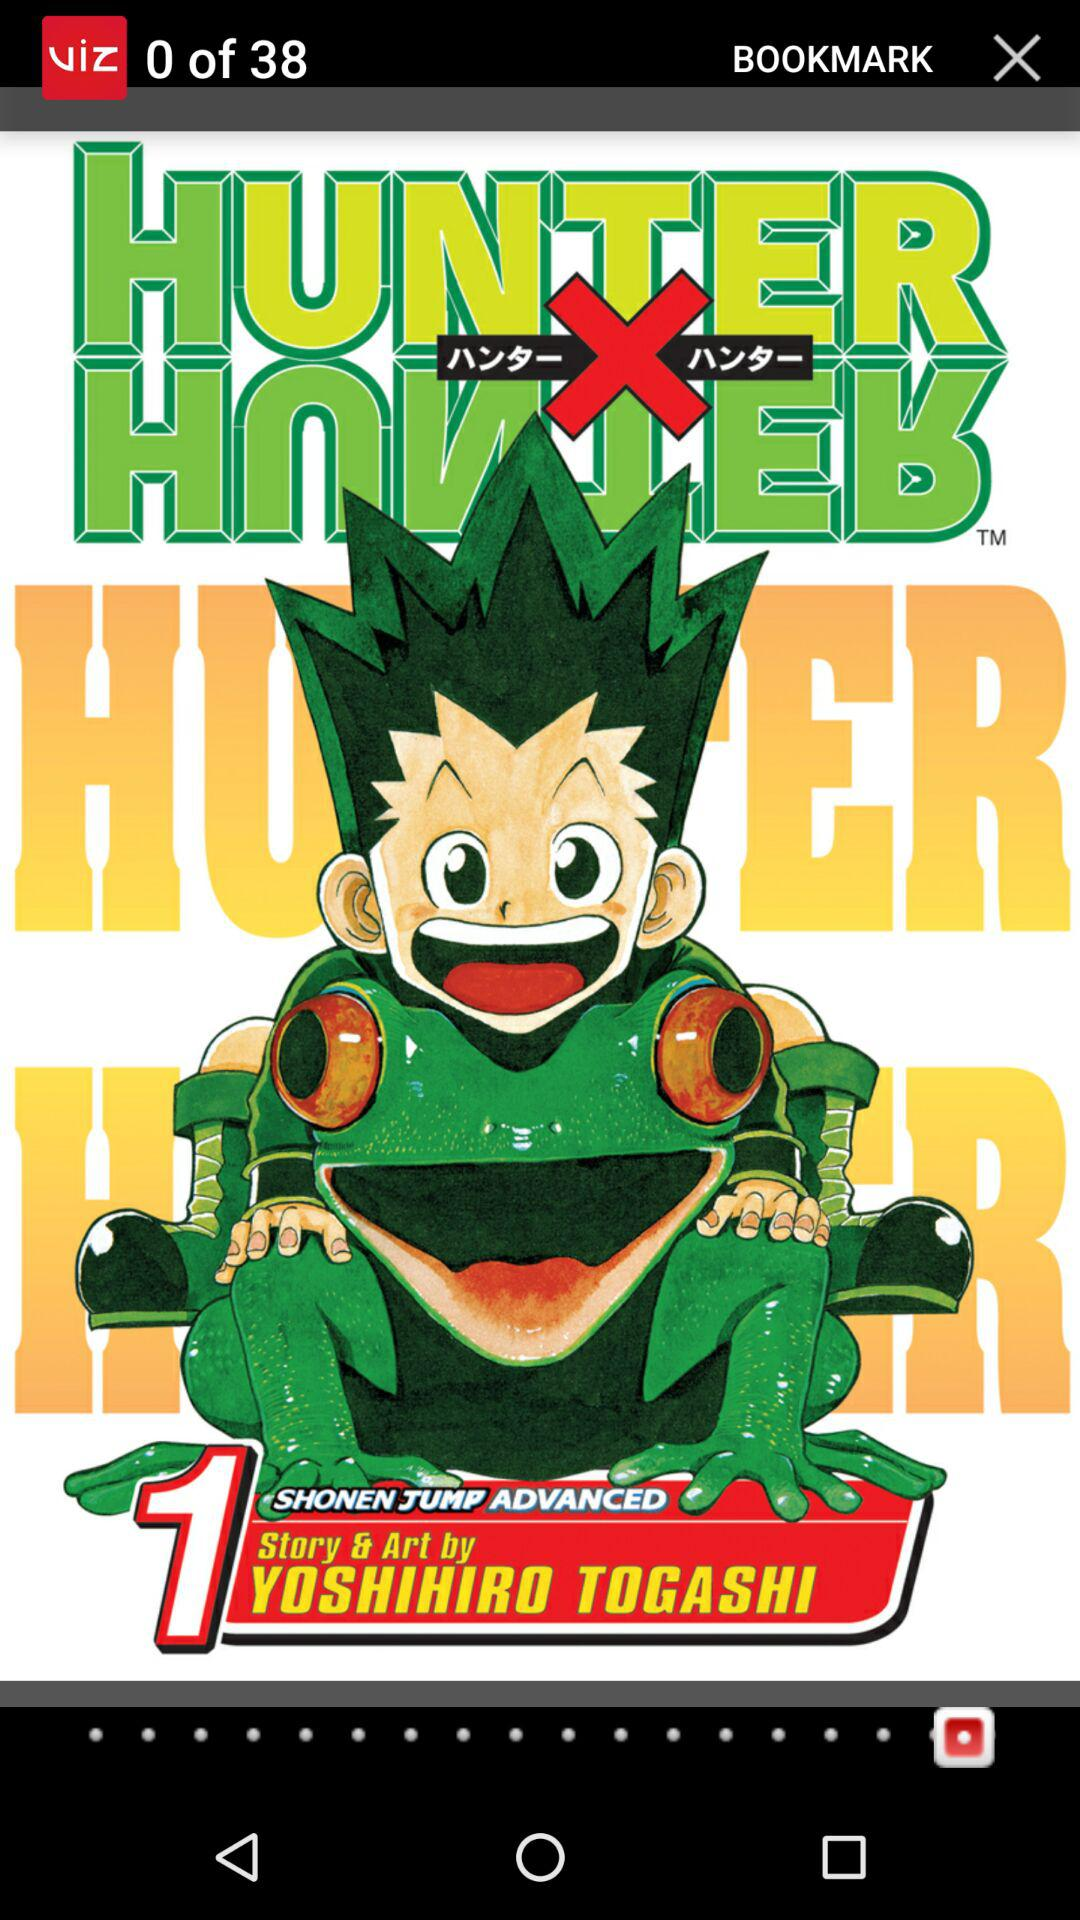Who is the artist? The artist is Yoshihiro Togashi. 